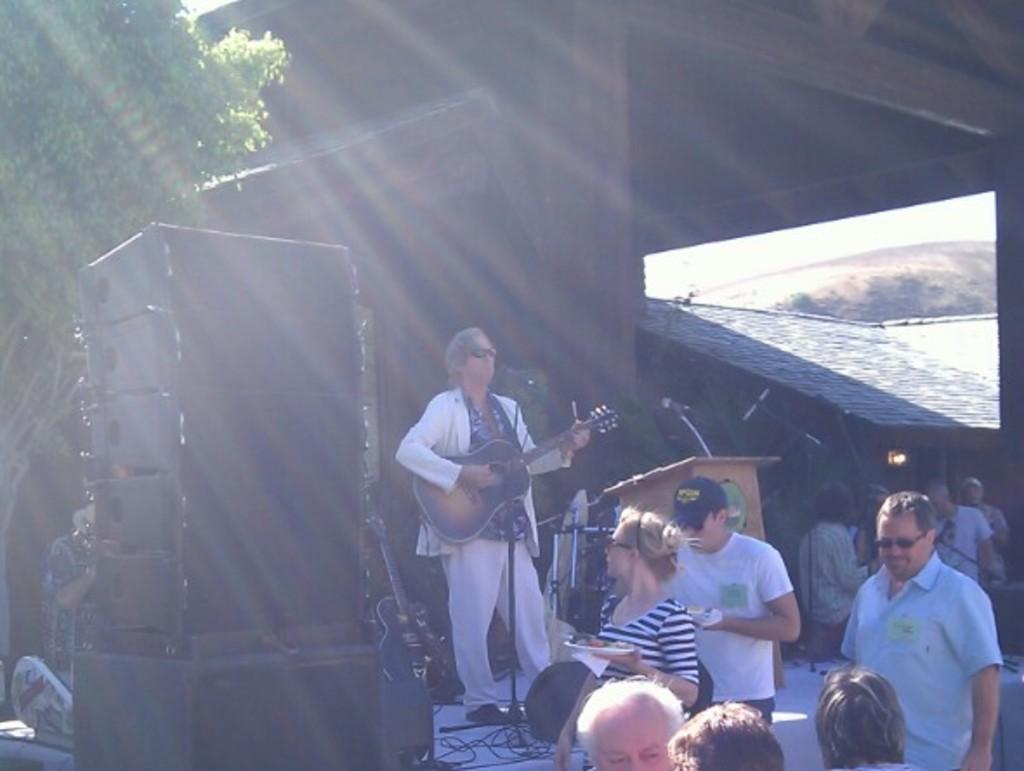In one or two sentences, can you explain what this image depicts? In this picture there is a man standing on the stage playing a guitar in his hand. He is wearing spectacles. In the down there are some people standing. We can observe a podium with a microphone here. In the background there are some trees. Here is a speaker. 